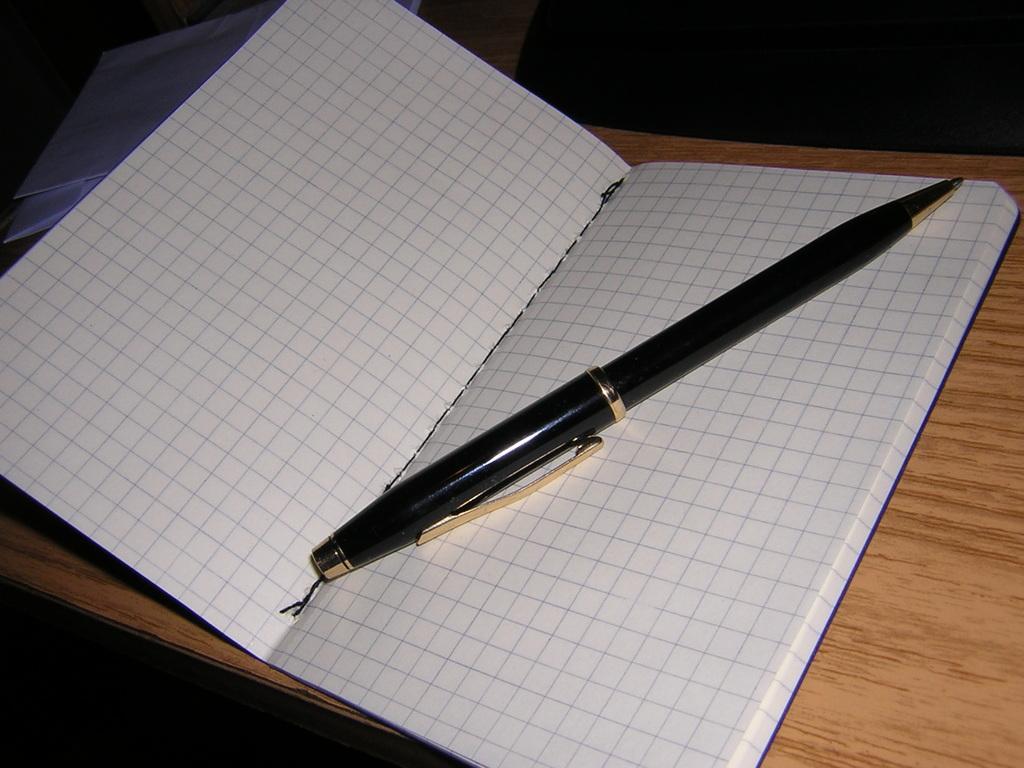In one or two sentences, can you explain what this image depicts? In the foreground of this image, there is a pen on a book which is on a wooden surface. At the top, there are two white color objects. 